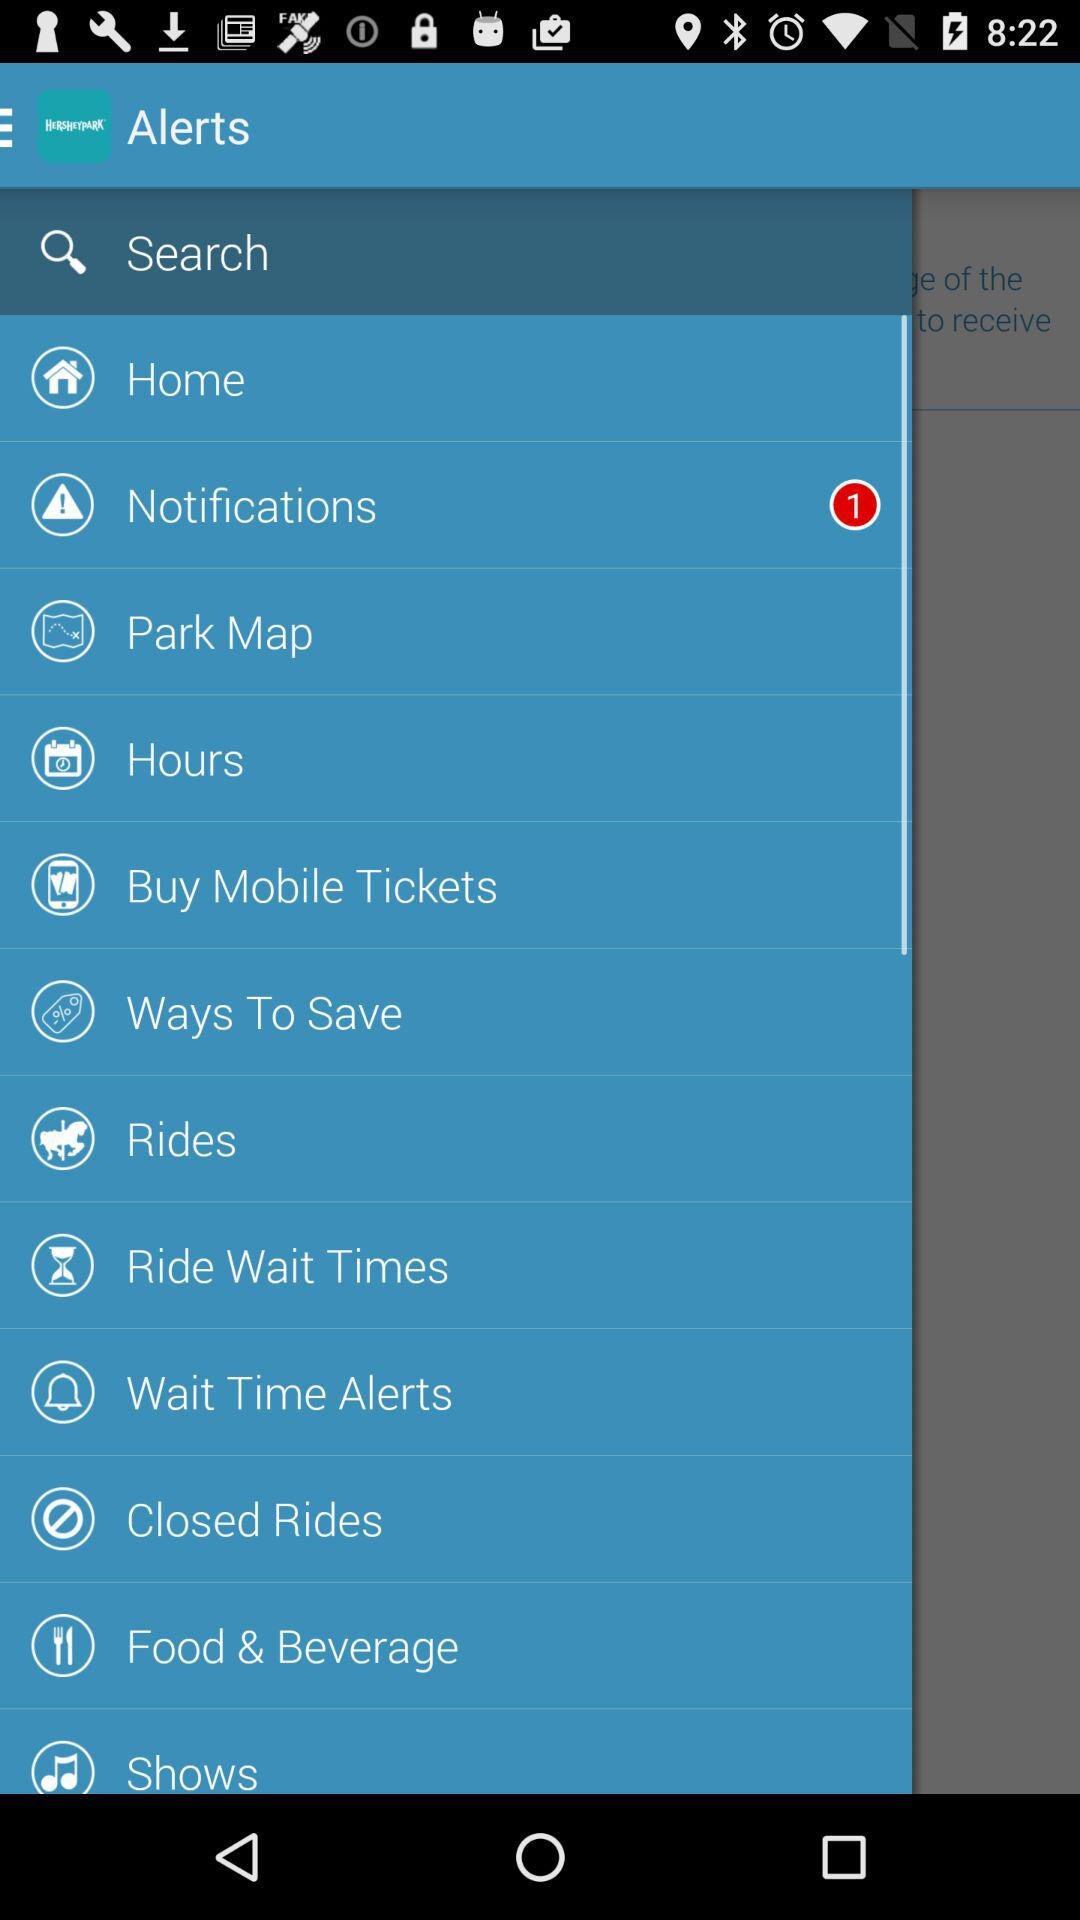How many notifications are unread? There is 1 unread notification. 